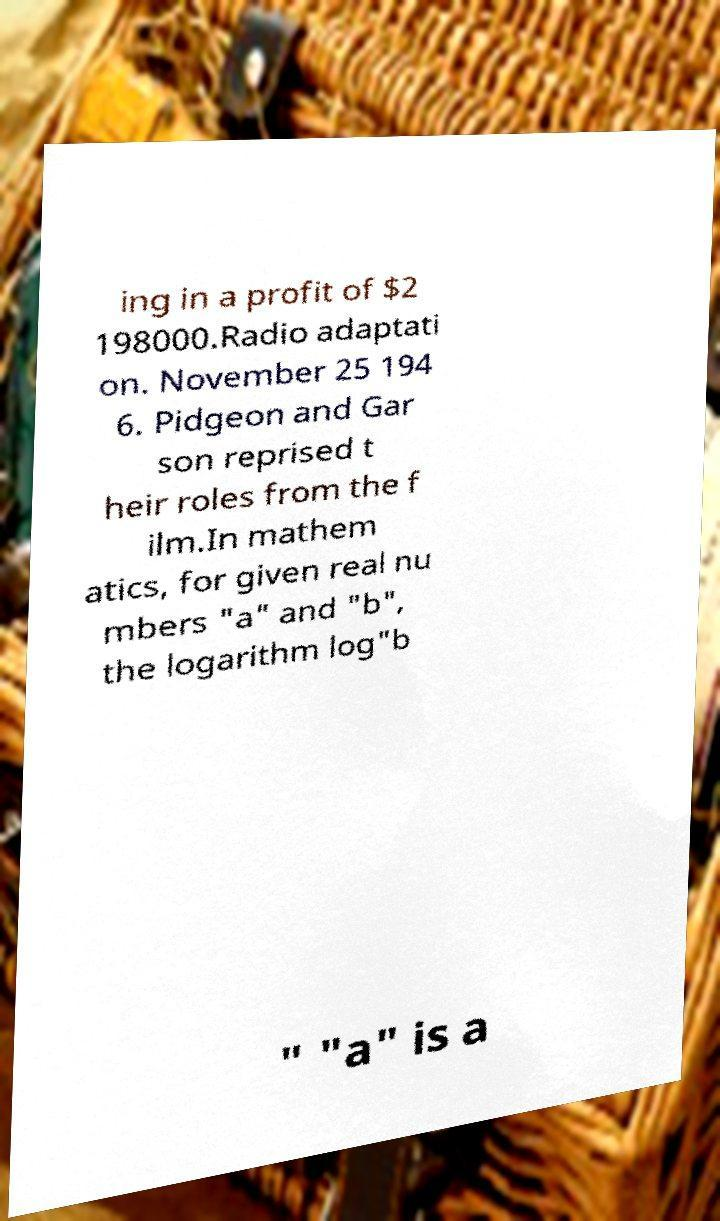There's text embedded in this image that I need extracted. Can you transcribe it verbatim? ing in a profit of $2 198000.Radio adaptati on. November 25 194 6. Pidgeon and Gar son reprised t heir roles from the f ilm.In mathem atics, for given real nu mbers "a" and "b", the logarithm log"b " "a" is a 